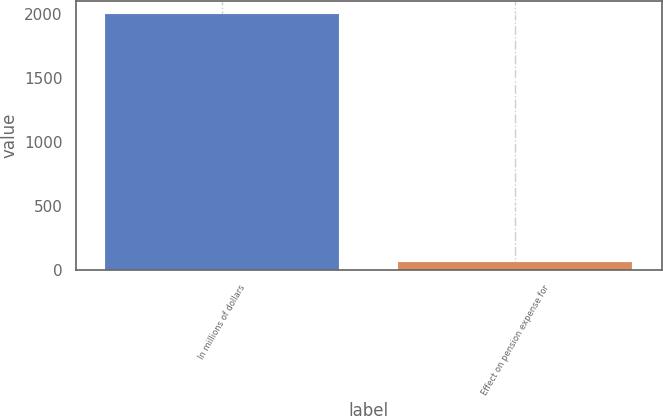Convert chart to OTSL. <chart><loc_0><loc_0><loc_500><loc_500><bar_chart><fcel>In millions of dollars<fcel>Effect on pension expense for<nl><fcel>2007<fcel>59<nl></chart> 